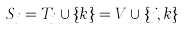<formula> <loc_0><loc_0><loc_500><loc_500>S _ { j } = T _ { j } \cup \{ k \} = V \cup \{ j , k \}</formula> 